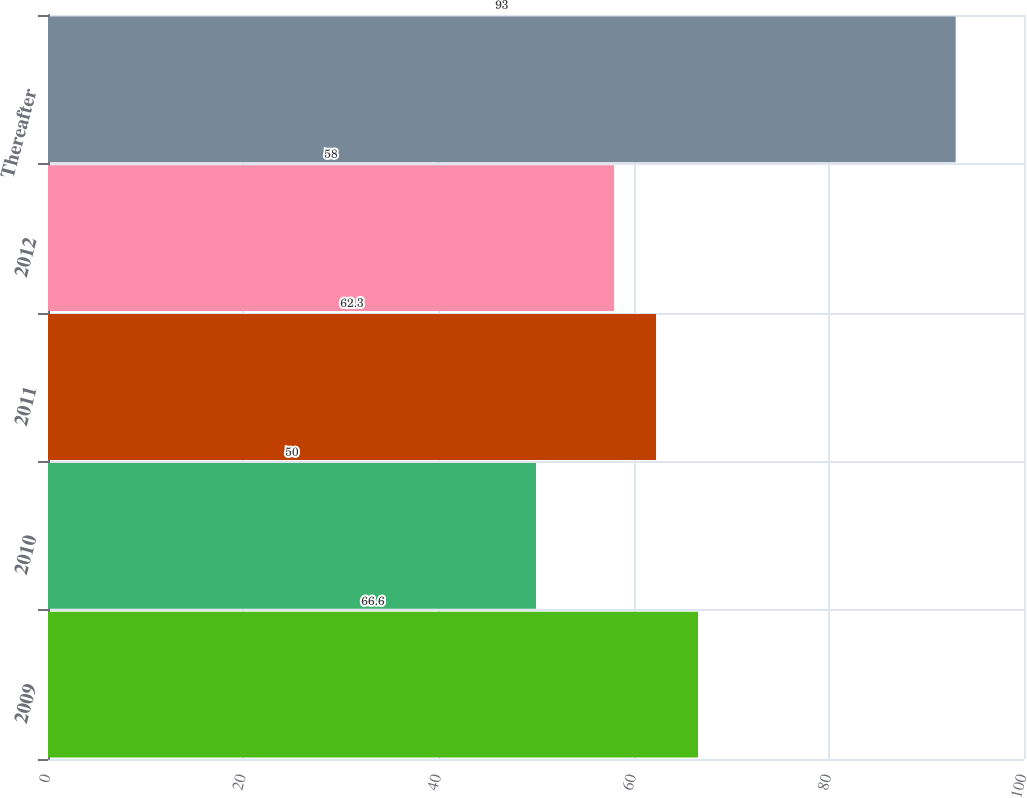Convert chart. <chart><loc_0><loc_0><loc_500><loc_500><bar_chart><fcel>2009<fcel>2010<fcel>2011<fcel>2012<fcel>Thereafter<nl><fcel>66.6<fcel>50<fcel>62.3<fcel>58<fcel>93<nl></chart> 